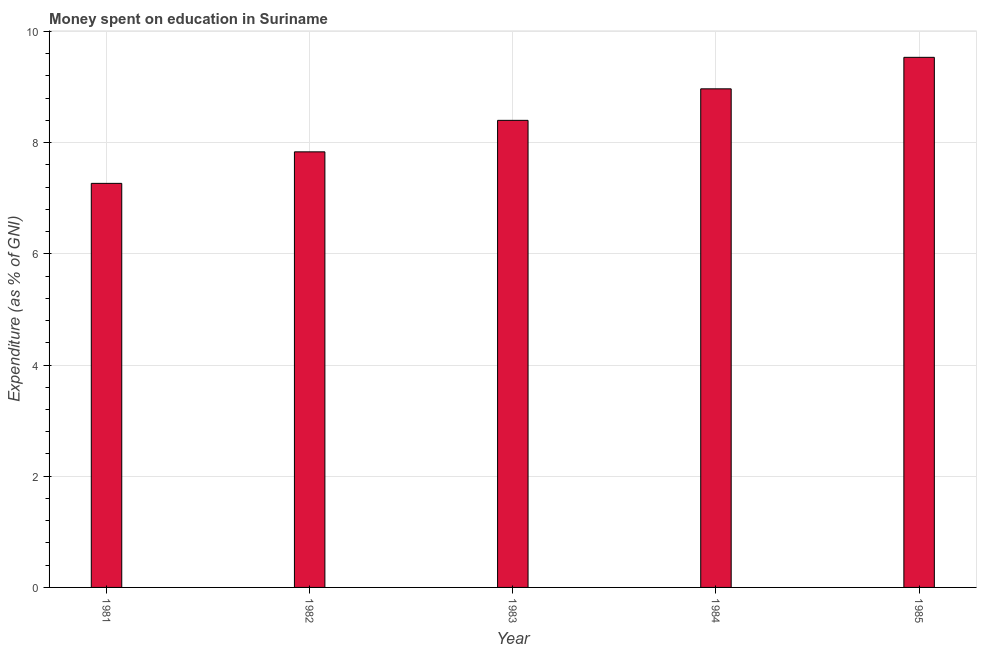Does the graph contain grids?
Ensure brevity in your answer.  Yes. What is the title of the graph?
Provide a succinct answer. Money spent on education in Suriname. What is the label or title of the Y-axis?
Give a very brief answer. Expenditure (as % of GNI). What is the expenditure on education in 1982?
Your answer should be compact. 7.83. Across all years, what is the maximum expenditure on education?
Give a very brief answer. 9.53. Across all years, what is the minimum expenditure on education?
Offer a terse response. 7.27. What is the sum of the expenditure on education?
Provide a succinct answer. 42. What is the difference between the expenditure on education in 1982 and 1983?
Offer a very short reply. -0.57. What is the average expenditure on education per year?
Give a very brief answer. 8.4. What is the median expenditure on education?
Your answer should be very brief. 8.4. In how many years, is the expenditure on education greater than 9.2 %?
Ensure brevity in your answer.  1. Do a majority of the years between 1985 and 1983 (inclusive) have expenditure on education greater than 5.2 %?
Provide a short and direct response. Yes. What is the ratio of the expenditure on education in 1981 to that in 1982?
Provide a short and direct response. 0.93. Is the difference between the expenditure on education in 1981 and 1985 greater than the difference between any two years?
Offer a very short reply. Yes. What is the difference between the highest and the second highest expenditure on education?
Your response must be concise. 0.57. Is the sum of the expenditure on education in 1982 and 1983 greater than the maximum expenditure on education across all years?
Your answer should be compact. Yes. What is the difference between the highest and the lowest expenditure on education?
Your response must be concise. 2.27. How many bars are there?
Give a very brief answer. 5. How many years are there in the graph?
Offer a terse response. 5. What is the difference between two consecutive major ticks on the Y-axis?
Your response must be concise. 2. Are the values on the major ticks of Y-axis written in scientific E-notation?
Give a very brief answer. No. What is the Expenditure (as % of GNI) of 1981?
Your answer should be compact. 7.27. What is the Expenditure (as % of GNI) in 1982?
Ensure brevity in your answer.  7.83. What is the Expenditure (as % of GNI) in 1983?
Your response must be concise. 8.4. What is the Expenditure (as % of GNI) in 1984?
Ensure brevity in your answer.  8.97. What is the Expenditure (as % of GNI) in 1985?
Ensure brevity in your answer.  9.53. What is the difference between the Expenditure (as % of GNI) in 1981 and 1982?
Keep it short and to the point. -0.57. What is the difference between the Expenditure (as % of GNI) in 1981 and 1983?
Offer a very short reply. -1.13. What is the difference between the Expenditure (as % of GNI) in 1981 and 1984?
Provide a short and direct response. -1.7. What is the difference between the Expenditure (as % of GNI) in 1981 and 1985?
Ensure brevity in your answer.  -2.27. What is the difference between the Expenditure (as % of GNI) in 1982 and 1983?
Your answer should be compact. -0.57. What is the difference between the Expenditure (as % of GNI) in 1982 and 1984?
Offer a very short reply. -1.13. What is the difference between the Expenditure (as % of GNI) in 1982 and 1985?
Make the answer very short. -1.7. What is the difference between the Expenditure (as % of GNI) in 1983 and 1984?
Offer a terse response. -0.57. What is the difference between the Expenditure (as % of GNI) in 1983 and 1985?
Your answer should be very brief. -1.13. What is the difference between the Expenditure (as % of GNI) in 1984 and 1985?
Give a very brief answer. -0.57. What is the ratio of the Expenditure (as % of GNI) in 1981 to that in 1982?
Your response must be concise. 0.93. What is the ratio of the Expenditure (as % of GNI) in 1981 to that in 1983?
Make the answer very short. 0.86. What is the ratio of the Expenditure (as % of GNI) in 1981 to that in 1984?
Your answer should be very brief. 0.81. What is the ratio of the Expenditure (as % of GNI) in 1981 to that in 1985?
Offer a very short reply. 0.76. What is the ratio of the Expenditure (as % of GNI) in 1982 to that in 1983?
Provide a short and direct response. 0.93. What is the ratio of the Expenditure (as % of GNI) in 1982 to that in 1984?
Ensure brevity in your answer.  0.87. What is the ratio of the Expenditure (as % of GNI) in 1982 to that in 1985?
Your answer should be very brief. 0.82. What is the ratio of the Expenditure (as % of GNI) in 1983 to that in 1984?
Provide a short and direct response. 0.94. What is the ratio of the Expenditure (as % of GNI) in 1983 to that in 1985?
Offer a terse response. 0.88. What is the ratio of the Expenditure (as % of GNI) in 1984 to that in 1985?
Make the answer very short. 0.94. 